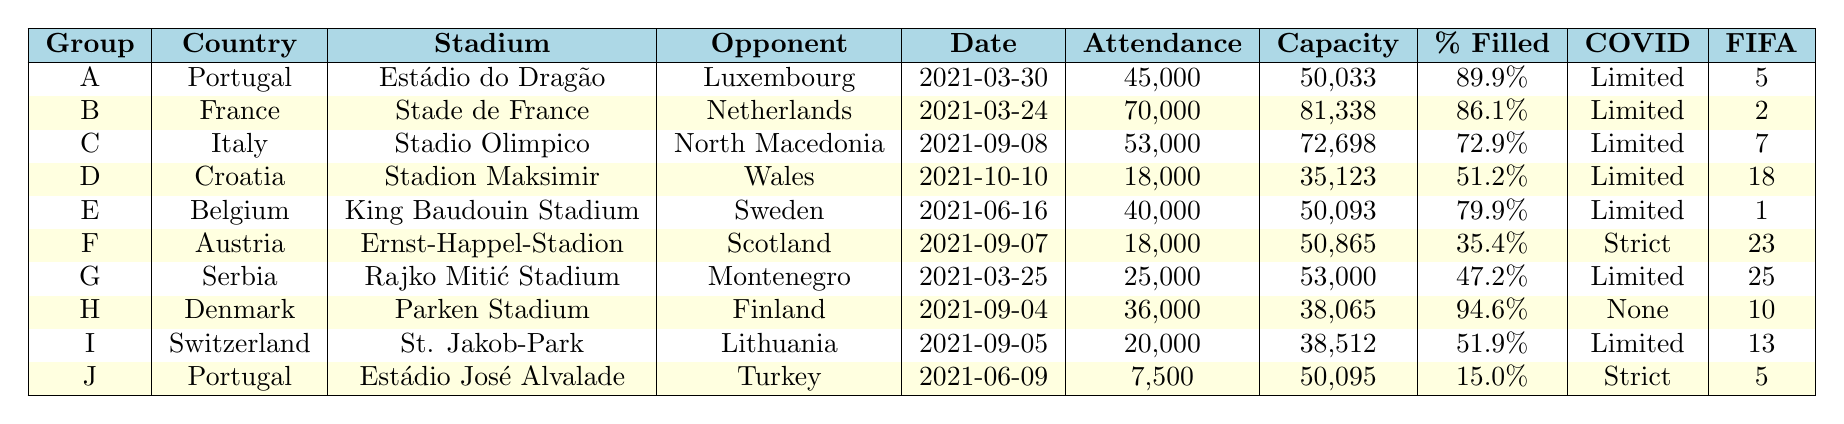What is the highest attendance recorded in the table? The attendances listed are 45,000, 70,000, 53,000, 18,000, 40,000, 18,000, 25,000, 36,000, 20,000, and 7,500. The highest number among these is 70,000.
Answer: 70,000 Which country had the lowest attendance? The attendances are 45,000, 70,000, 53,000, 18,000, 40,000, 18,000, 25,000, 36,000, 20,000, and 7,500. The lowest attendance is 7,500.
Answer: 7,500 What percentage of the Stade de France was filled? The percentage filled for the Stade de France is provided as 86.1%.
Answer: 86.1% Is there a country with an attendance below 30,000? The attendances listed include values of 18,000 and 7,500, which are both below 30,000. Therefore, yes, there is a country with attendance below 30,000.
Answer: Yes How many countries had attendance figures above 40,000? The attendance figures above 40,000 are 45,000, 70,000, and 53,000, corresponding to three countries.
Answer: 3 What was the average attendance across all matches? The total attendance is 45,000 + 70,000 + 53,000 + 18,000 + 40,000 + 18,000 + 25,000 + 36,000 + 20,000 + 7,500 =  392,500. There are 10 matches, so the average is 392,500 / 10 = 39,250.
Answer: 39,250 Which country had a higher attendance, Belgium or Croatia? Belgium's attendance was 40,000 and Croatia's was 18,000. Since 40,000 is greater than 18,000, Belgium had a higher attendance.
Answer: Belgium How does the attendance of the home team with the lowest FIFA ranking compare to the one with the highest FIFA ranking? Serbia has the lowest FIFA ranking of 25 with an attendance of 25,000, and Belgium has the highest ranking (1) with 40,000. 40,000 - 25,000 = 15,000 difference in attendance.
Answer: 15,000 Did any stadiums have a capacity that was more than 80,000? The table shows Stade de France with a capacity of 81,338, which is above 80,000. Therefore, the answer is yes.
Answer: Yes Which team played in front of the highest percentage filled stadium? Denmark played in front of the Parken Stadium which had a percentage filled of 94.6%, the highest in the table.
Answer: Denmark 